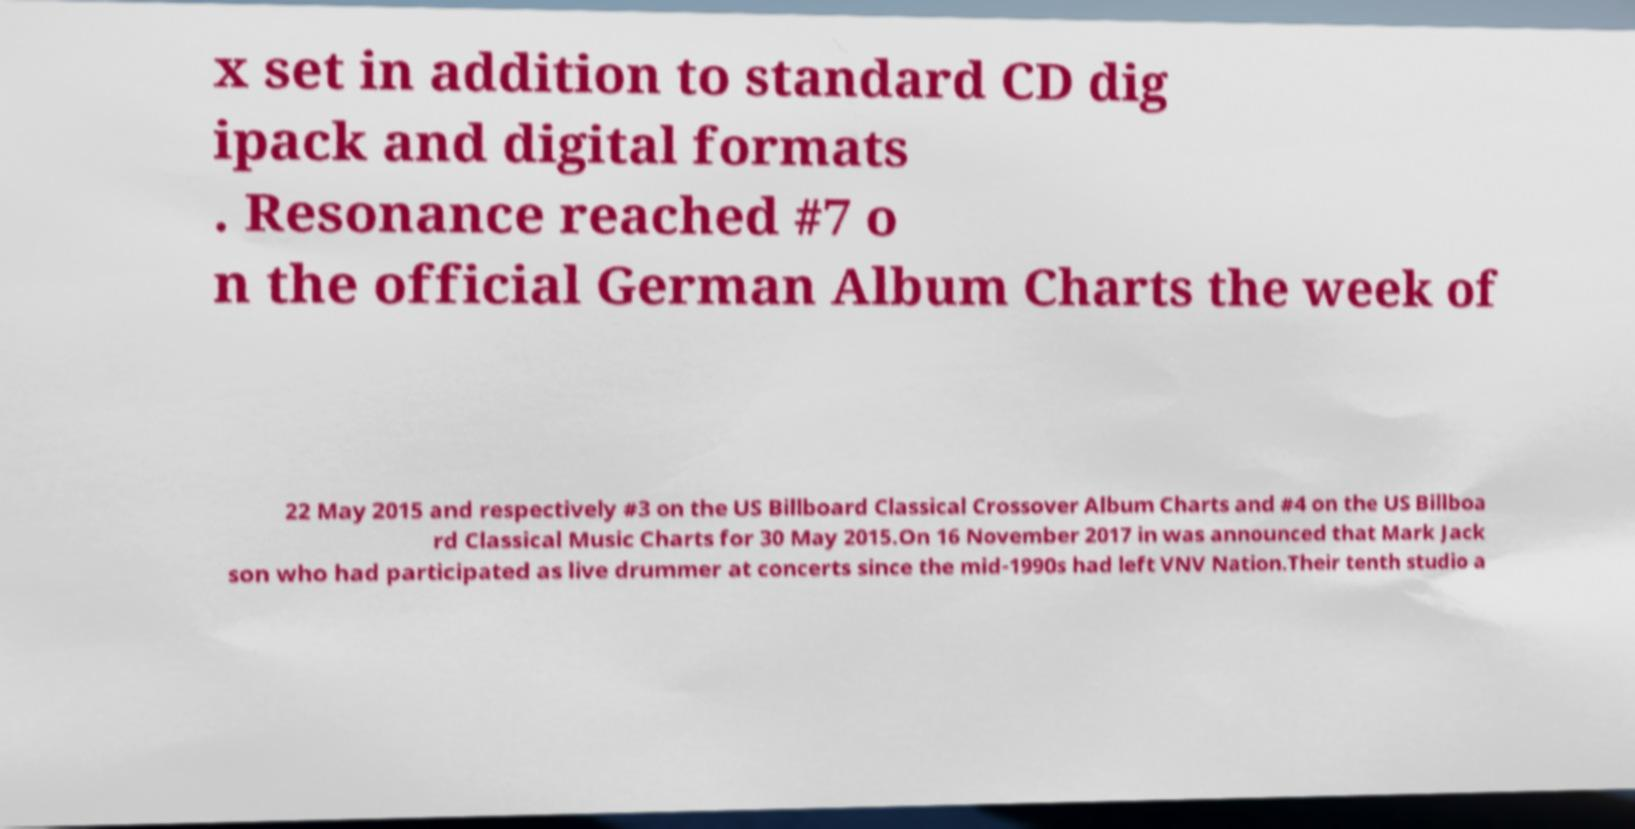Please read and relay the text visible in this image. What does it say? x set in addition to standard CD dig ipack and digital formats . Resonance reached #7 o n the official German Album Charts the week of 22 May 2015 and respectively #3 on the US Billboard Classical Crossover Album Charts and #4 on the US Billboa rd Classical Music Charts for 30 May 2015.On 16 November 2017 in was announced that Mark Jack son who had participated as live drummer at concerts since the mid-1990s had left VNV Nation.Their tenth studio a 